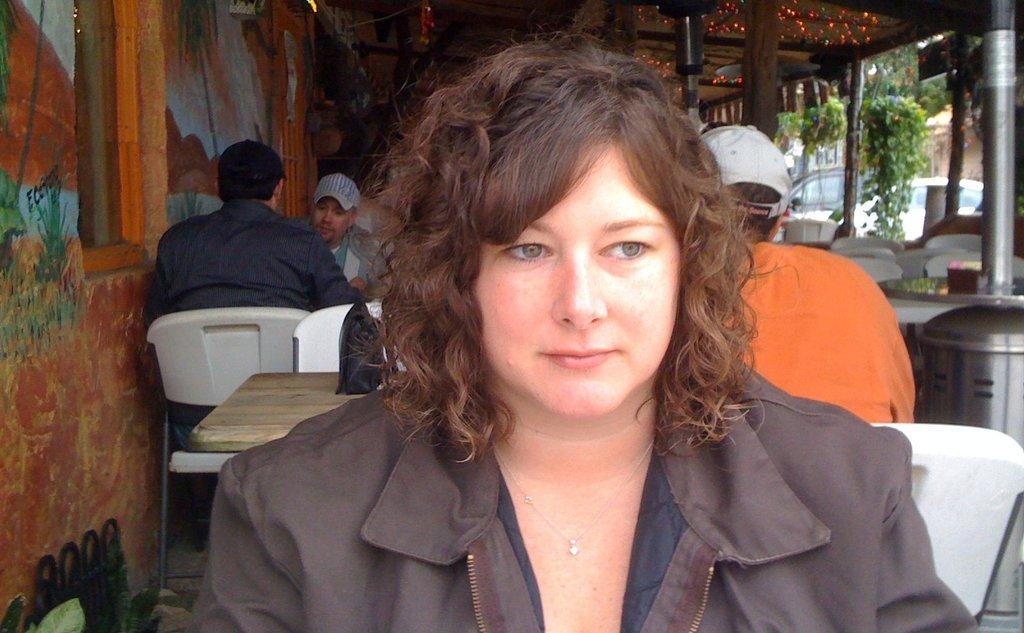Could you give a brief overview of what you see in this image? In this picture there are group of people sitting on the chair. At the top there are lights. At the left there is a window and there is a painting on the wall. At the right there are cars and trees. 